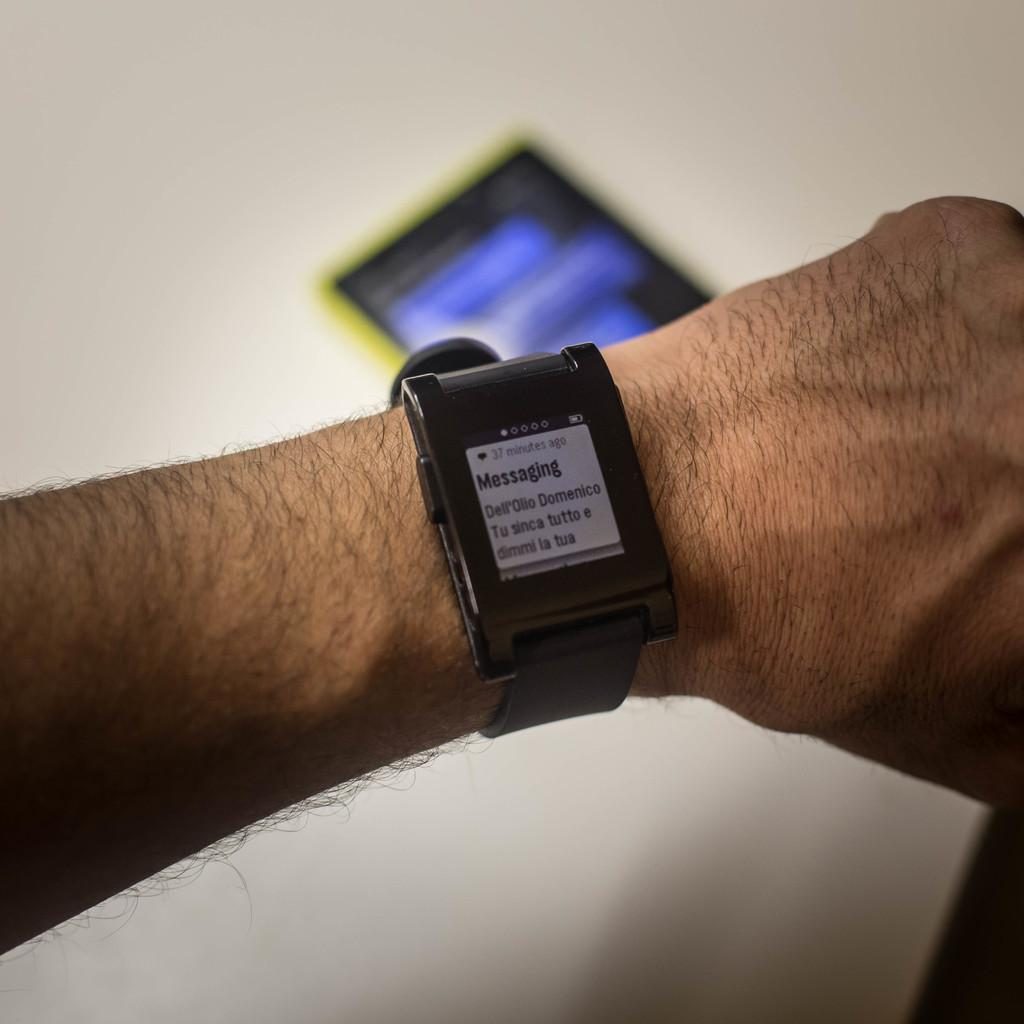<image>
Present a compact description of the photo's key features. A smart watch on a wrist displaying a message. 